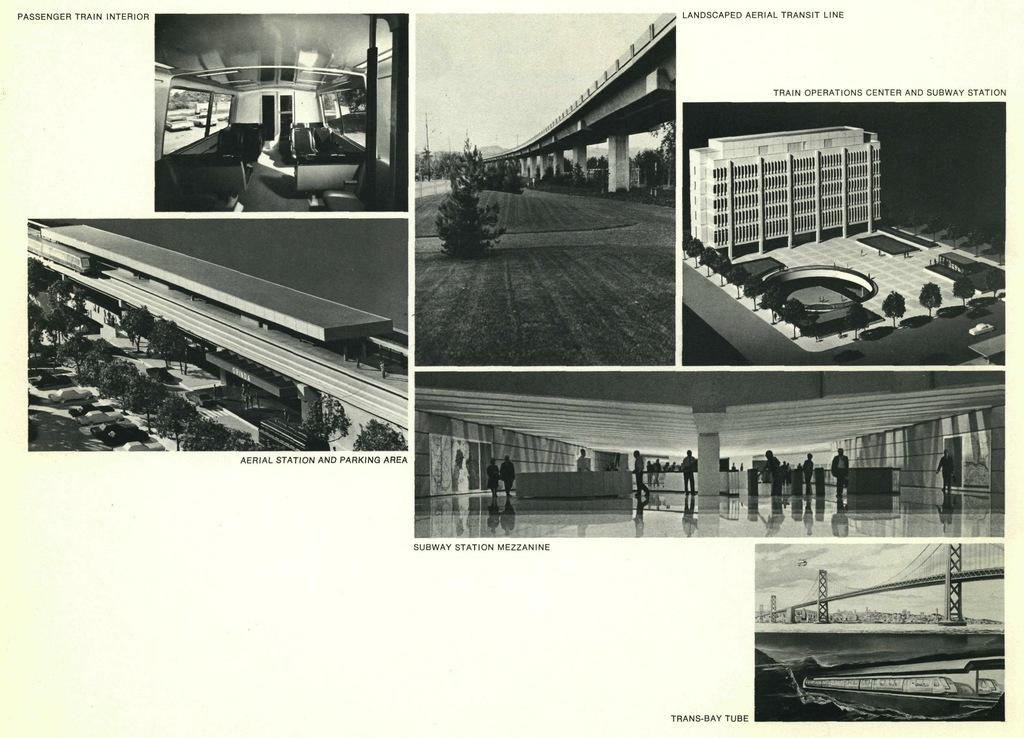What type of photo is shown in the image? The image is a collage photo. What type of structure can be seen in the image? There is a bridge in the image. What type of natural elements are present in the image? There are trees in the image. What type of transportation is visible in the image? Vehicles are present in the image. What type of watercraft is in the image? There is a boat in the image. What part of the natural environment is visible in the image? The sky is visible in the image. What type of group is present in the image? A group of people is in the image. What type of lunchroom can be seen in the image? There is no lunchroom present in the image. What type of verse is written on the bridge in the image? There is no verse written on the bridge in the image. 